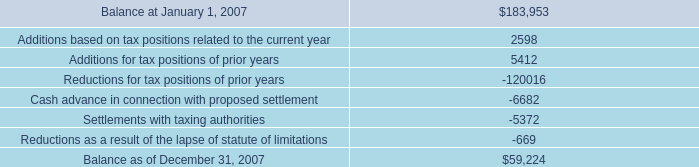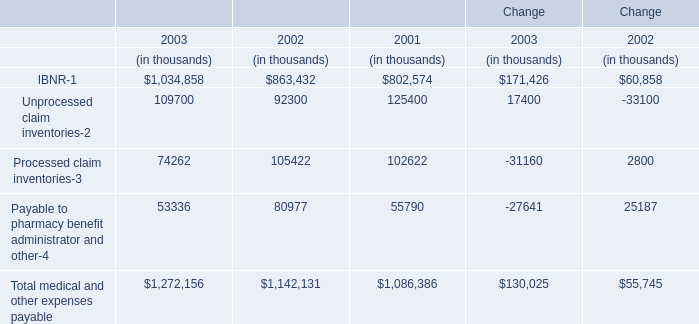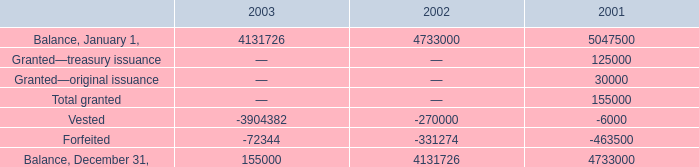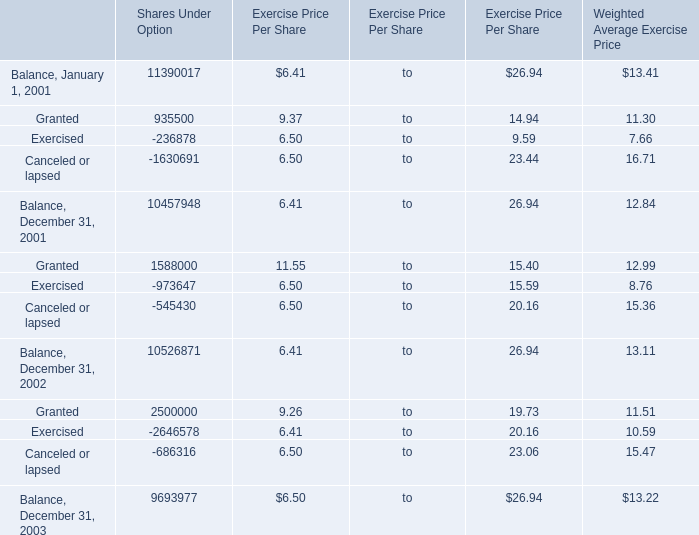What is the average amount of Balance, December 31, 2001 of Shares Under Option, and Balance, January 1, of 2003 ? 
Computations: ((10457948.0 + 4131726.0) / 2)
Answer: 7294837.0. 